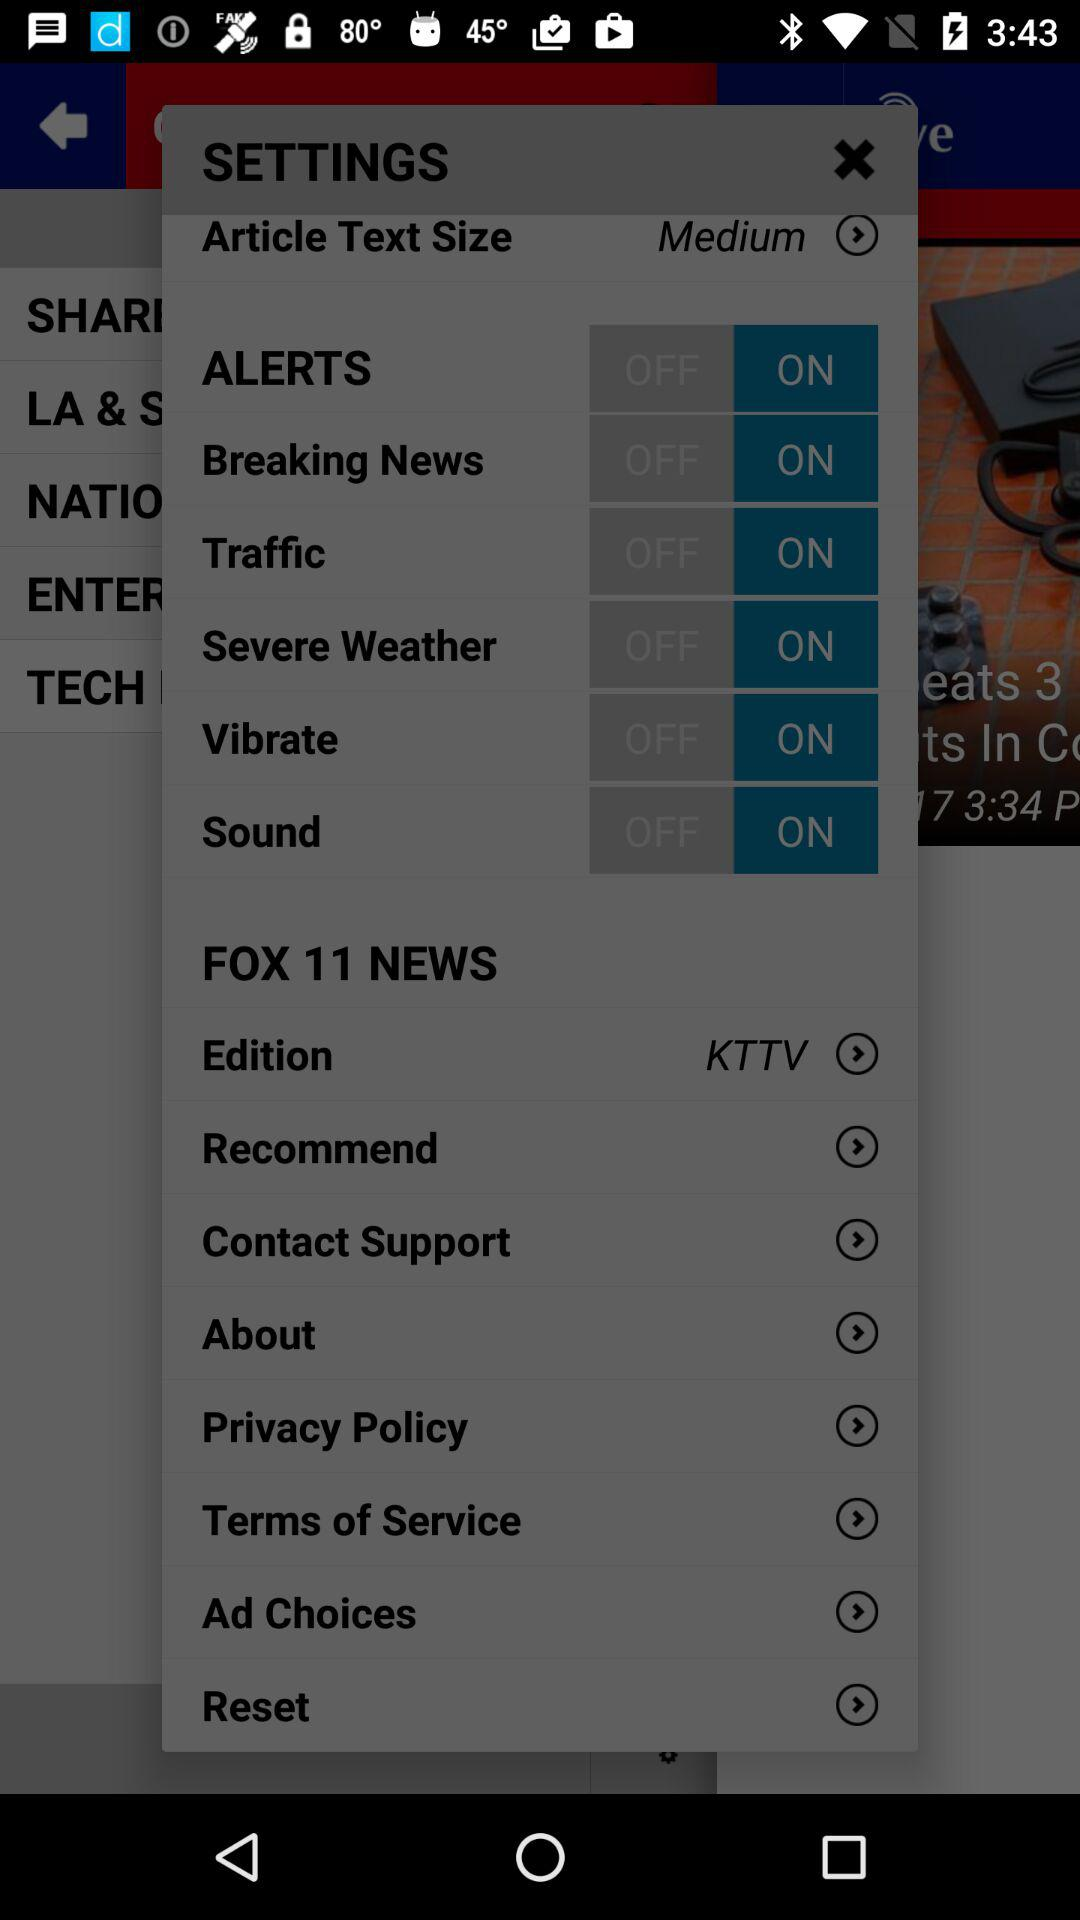What is the status of "Sound"? The status is "on". 